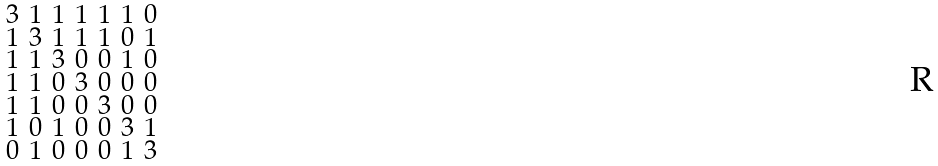Convert formula to latex. <formula><loc_0><loc_0><loc_500><loc_500>\begin{smallmatrix} 3 & 1 & 1 & 1 & 1 & 1 & 0 \\ 1 & 3 & 1 & 1 & 1 & 0 & 1 \\ 1 & 1 & 3 & 0 & 0 & 1 & 0 \\ 1 & 1 & 0 & 3 & 0 & 0 & 0 \\ 1 & 1 & 0 & 0 & 3 & 0 & 0 \\ 1 & 0 & 1 & 0 & 0 & 3 & 1 \\ 0 & 1 & 0 & 0 & 0 & 1 & 3 \end{smallmatrix}</formula> 